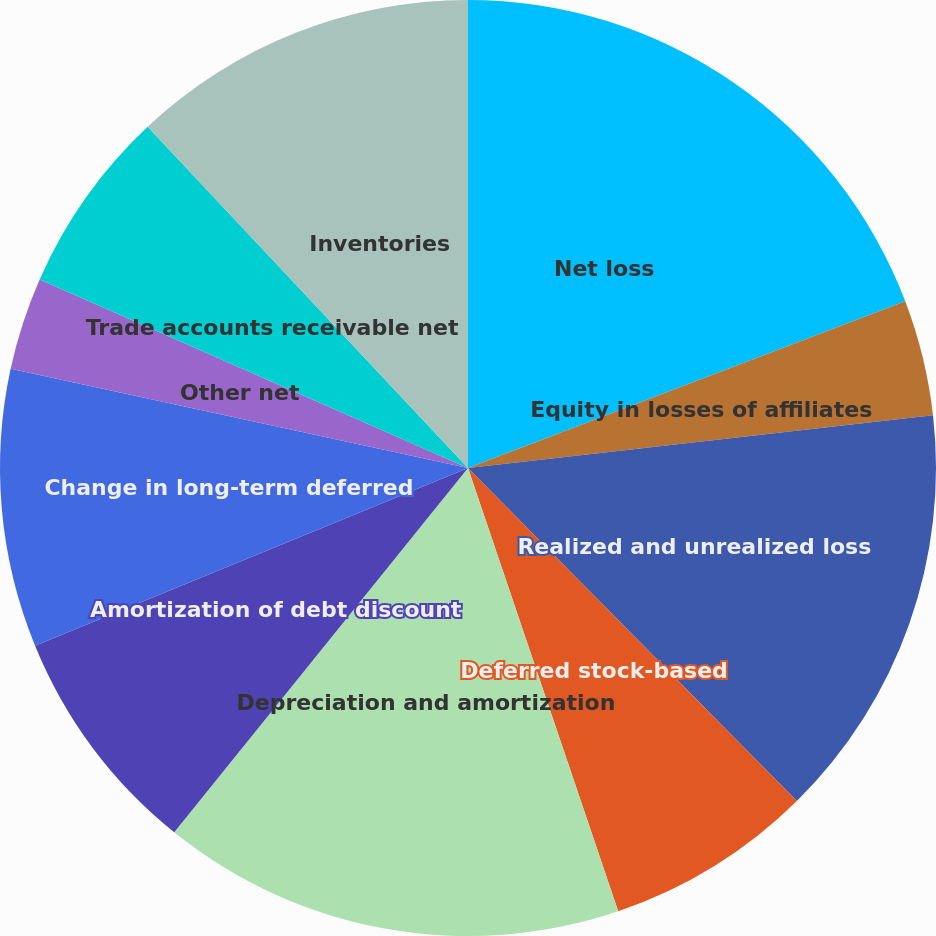Convert chart. <chart><loc_0><loc_0><loc_500><loc_500><pie_chart><fcel>Net loss<fcel>Equity in losses of affiliates<fcel>Realized and unrealized loss<fcel>Deferred stock-based<fcel>Depreciation and amortization<fcel>Amortization of debt discount<fcel>Change in long-term deferred<fcel>Other net<fcel>Trade accounts receivable net<fcel>Inventories<nl><fcel>19.2%<fcel>4.0%<fcel>14.4%<fcel>7.2%<fcel>16.0%<fcel>8.0%<fcel>9.6%<fcel>3.2%<fcel>6.4%<fcel>12.0%<nl></chart> 